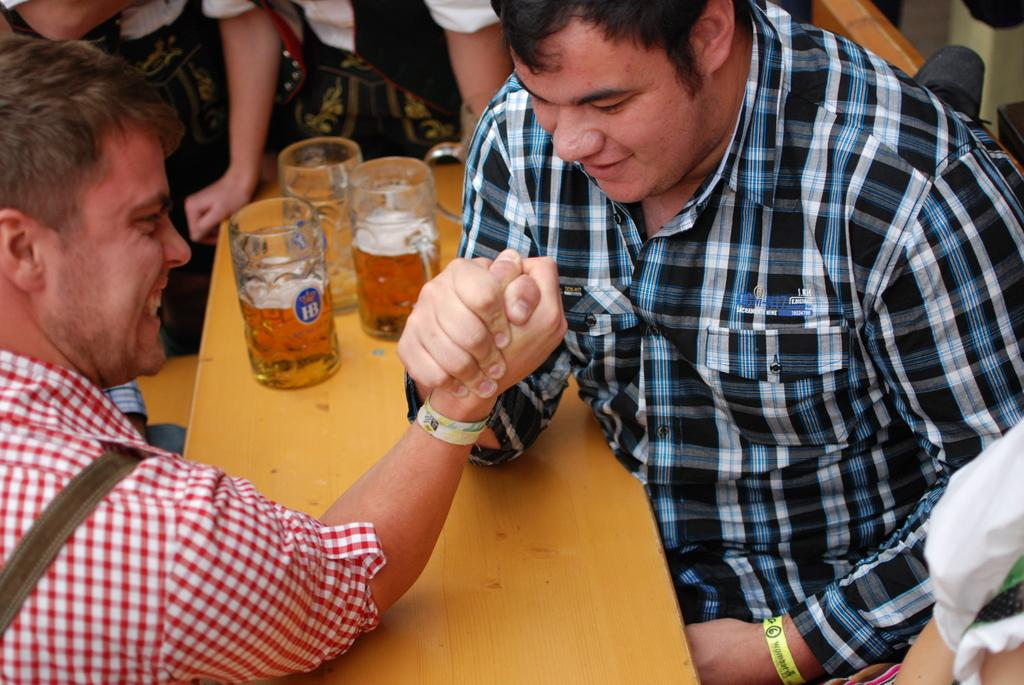How many people are in the image? There are two people in the image. What are the two people doing in the image? The two people are engaged in a fistfight. Where is the fistfight taking place? The fistfight is taking place on a table. What else can be seen on the table besides the fistfight? There are three glasses on the table. What type of potato is being used as a weapon in the fistfight? There is no potato present in the image, nor is it being used as a weapon in the fistfight. 